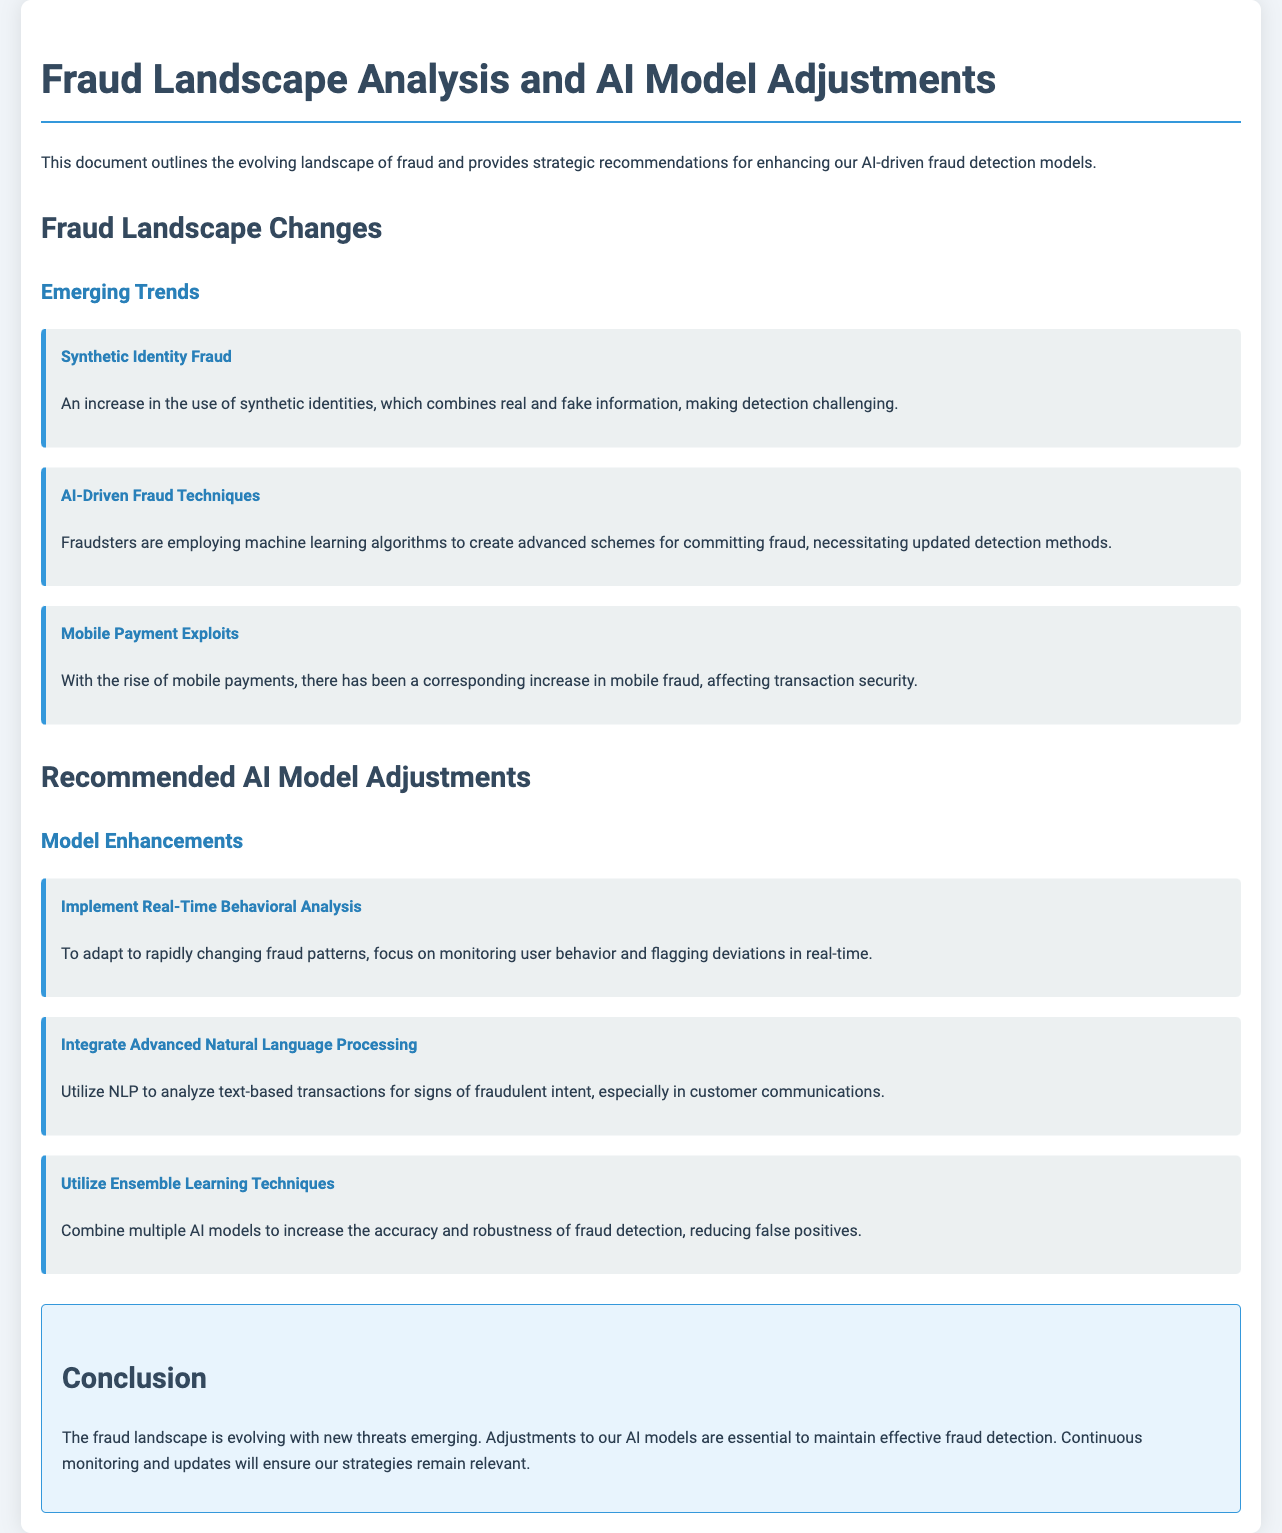What are the emerging trends in fraud? The document lists synthetic identity fraud, AI-driven fraud techniques, and mobile payment exploits as emerging trends in the fraud landscape.
Answer: Synthetic identity fraud, AI-driven fraud techniques, mobile payment exploits What is recommended for real-time fraud detection? The document recommends implementing real-time behavioral analysis to adapt to rapidly changing fraud patterns.
Answer: Real-time behavioral analysis What advanced technique is suggested for analyzing text? The document suggests integrating advanced natural language processing (NLP) to analyze text-based transactions for signs of fraudulent intent.
Answer: Advanced natural language processing What is the main conclusion of the document? The conclusion states that adjustments to AI models are essential to maintain effective fraud detection due to the evolving fraud landscape.
Answer: Adjustments to AI models are essential How many specific types of fraud trends are mentioned? The document outlines three specific types of fraud trends as emerging challenges in the landscape.
Answer: Three 